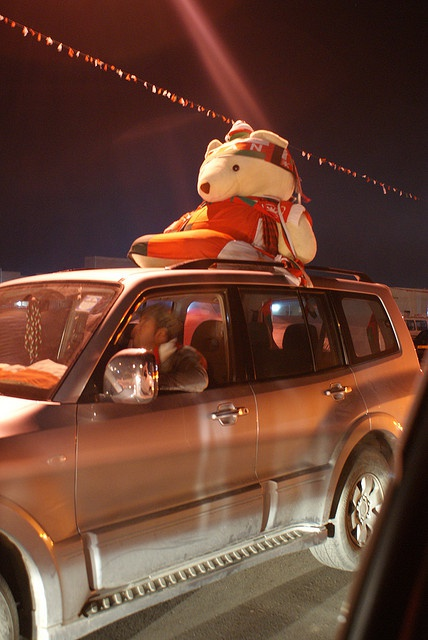Describe the objects in this image and their specific colors. I can see car in maroon, brown, and black tones, teddy bear in maroon, tan, brown, and red tones, and people in maroon and brown tones in this image. 